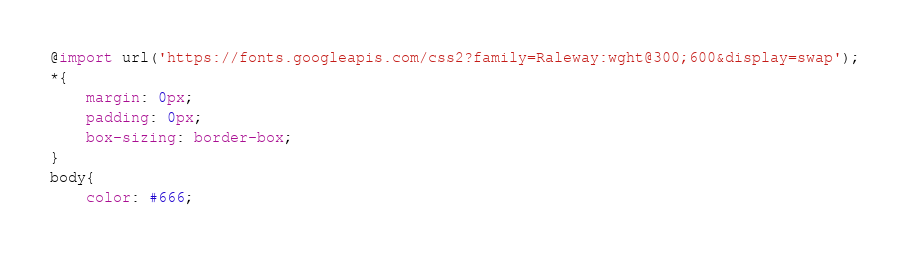Convert code to text. <code><loc_0><loc_0><loc_500><loc_500><_CSS_>@import url('https://fonts.googleapis.com/css2?family=Raleway:wght@300;600&display=swap');
*{
    margin: 0px;
    padding: 0px;
    box-sizing: border-box;
}
body{
    color: #666;</code> 